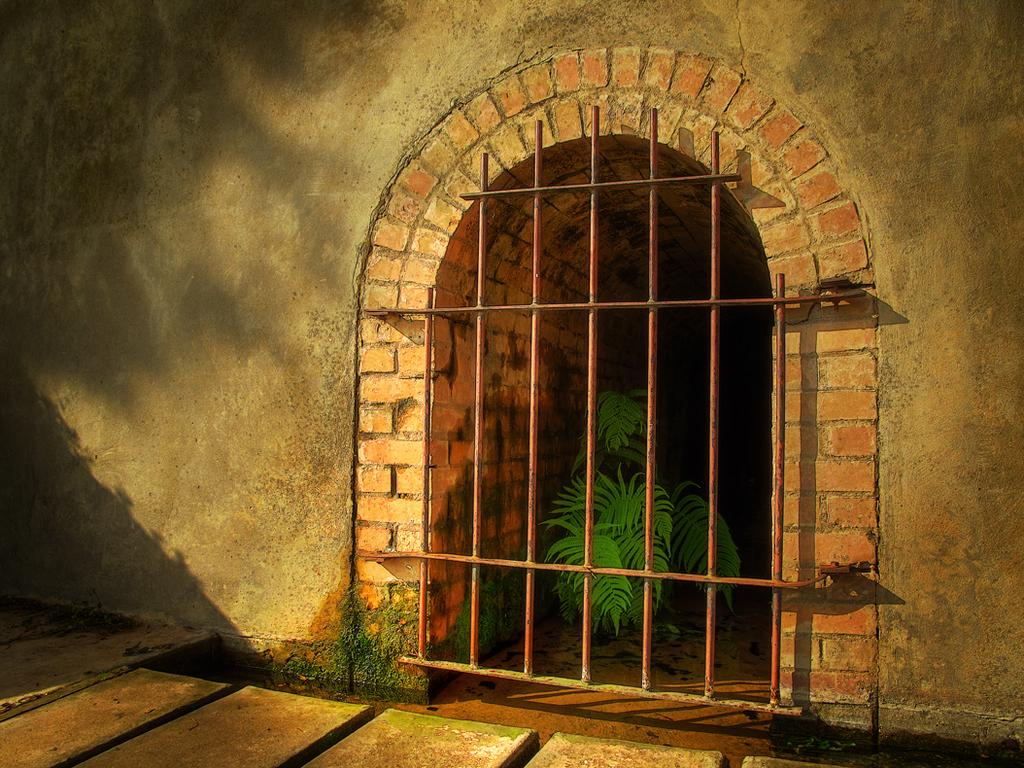What type of material is used for the planks in the image? The wooden planks in the image are made of wood. What is the structure made of metal in the image? There is a metal gate in the image. What is located behind the metal gate? There is a plant behind the metal gate. What is the background of the image made of? There is a wall in the image. How many eyes can be seen on the wooden planks in the image? There are no eyes present on the wooden planks in the image. Can you describe the sound of the plant sneezing in the image? Plants do not have the ability to sneeze, so there is no sound of a plant sneezing in the image. 